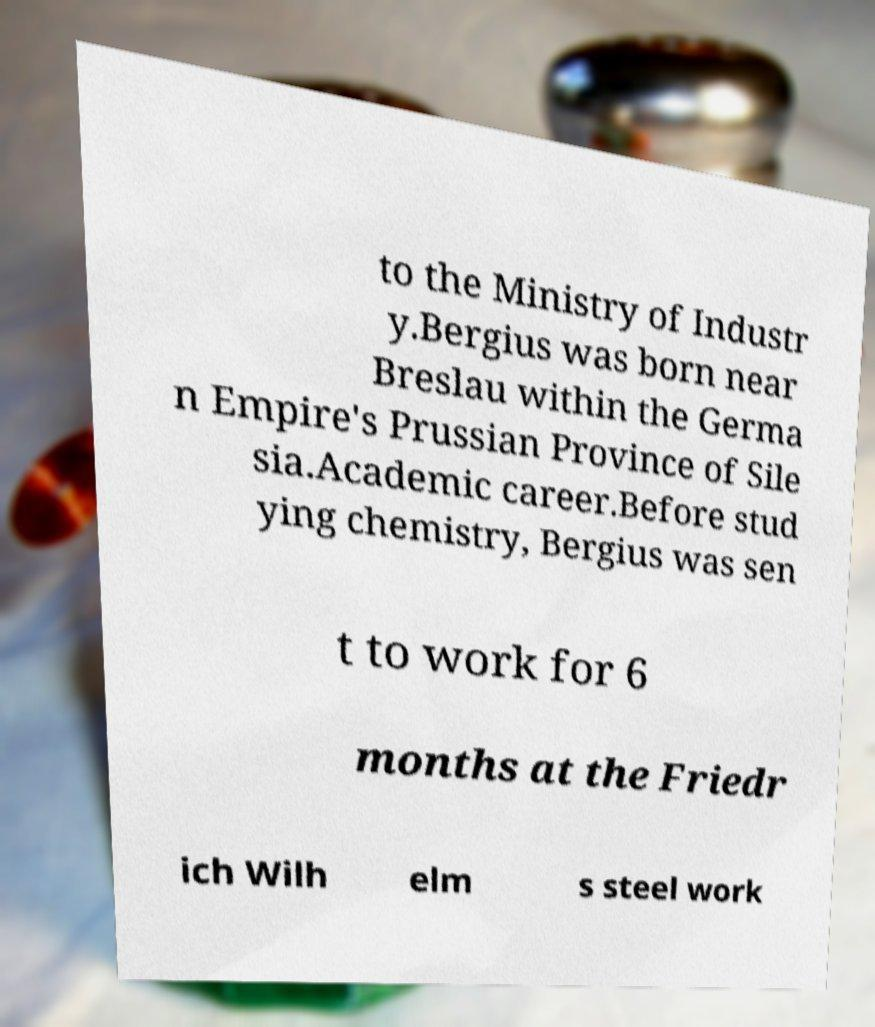Can you read and provide the text displayed in the image?This photo seems to have some interesting text. Can you extract and type it out for me? to the Ministry of Industr y.Bergius was born near Breslau within the Germa n Empire's Prussian Province of Sile sia.Academic career.Before stud ying chemistry, Bergius was sen t to work for 6 months at the Friedr ich Wilh elm s steel work 